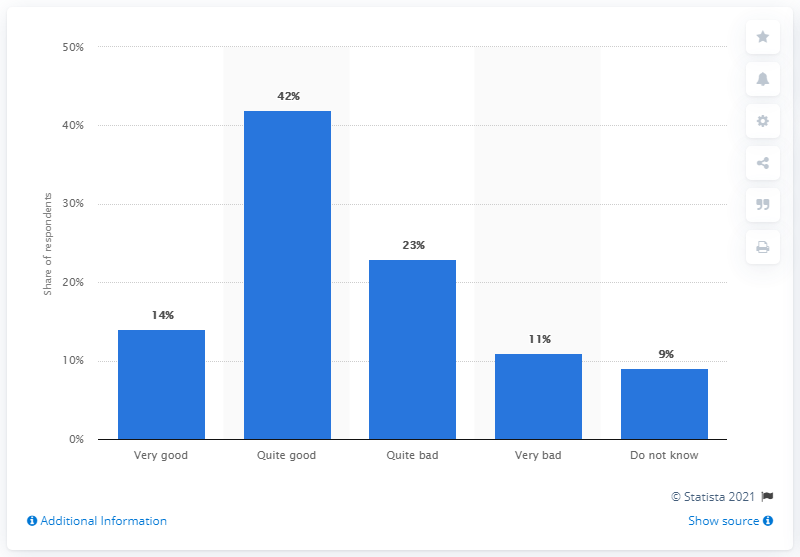Mention a couple of crucial points in this snapshot. According to a recent survey, 11% of Finns believed that the COVID-19 outbreak was very poorly managed. 